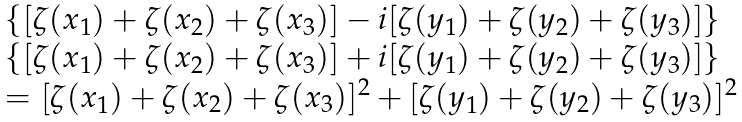<formula> <loc_0><loc_0><loc_500><loc_500>\begin{array} { l c r } \{ [ \zeta ( x _ { 1 } ) + \zeta ( x _ { 2 } ) + \zeta ( x _ { 3 } ) ] - i [ \zeta ( y _ { 1 } ) + \zeta ( y _ { 2 } ) + \zeta ( y _ { 3 } ) ] \} & \\ \{ [ \zeta ( x _ { 1 } ) + \zeta ( x _ { 2 } ) + \zeta ( x _ { 3 } ) ] + i [ \zeta ( y _ { 1 } ) + \zeta ( y _ { 2 } ) + \zeta ( y _ { 3 } ) ] \} & \\ = [ \zeta ( x _ { 1 } ) + \zeta ( x _ { 2 } ) + \zeta ( x _ { 3 } ) ] ^ { 2 } + [ \zeta ( y _ { 1 } ) + \zeta ( y _ { 2 } ) + \zeta ( y _ { 3 } ) ] ^ { 2 } \end{array}</formula> 